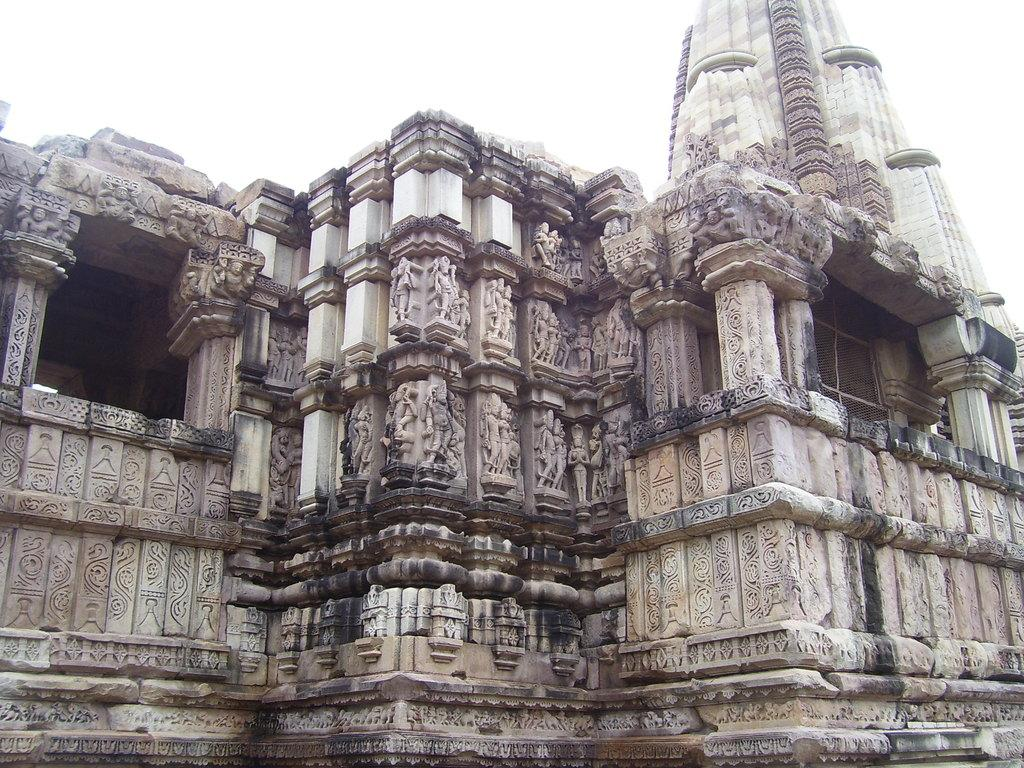What type of structure is in the image? There is a temple in the image. What architectural features can be seen on the temple? The temple has pillars, sculptures, and carvings. What is visible at the top of the image? The sky is visible at the top of the image. What can be seen on the right side of the image? There is a mesh on the right side of the image. What color is the brain on the left side of the image? There is no brain present in the image; it features a temple with architectural features and a mesh on the right side. 